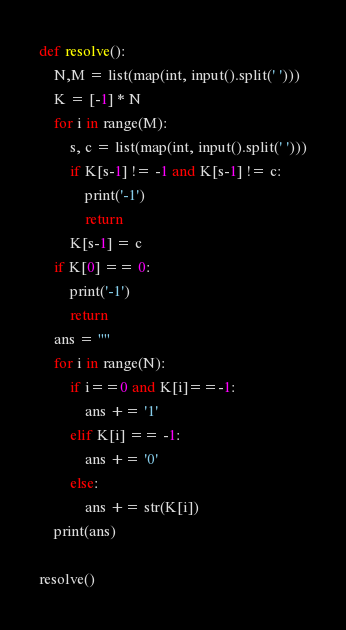Convert code to text. <code><loc_0><loc_0><loc_500><loc_500><_Python_>def resolve():
    N,M = list(map(int, input().split(' ')))
    K = [-1] * N
    for i in range(M):
        s, c = list(map(int, input().split(' ')))
        if K[s-1] != -1 and K[s-1] != c:
            print('-1')
            return
        K[s-1] = c
    if K[0] == 0:
        print('-1')
        return
    ans = ""
    for i in range(N):
        if i==0 and K[i]==-1:
            ans += '1'
        elif K[i] == -1:
            ans += '0'
        else:
            ans += str(K[i])
    print(ans)

resolve()</code> 